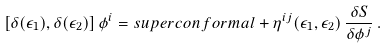Convert formula to latex. <formula><loc_0><loc_0><loc_500><loc_500>\left [ \delta ( \epsilon _ { 1 } ) , \delta ( \epsilon _ { 2 } ) \right ] \phi ^ { i } = s u p e r c o n f o r m a l + \eta ^ { i j } ( \epsilon _ { 1 } , \epsilon _ { 2 } ) \, \frac { \delta S } { \delta \phi ^ { j } } \, .</formula> 